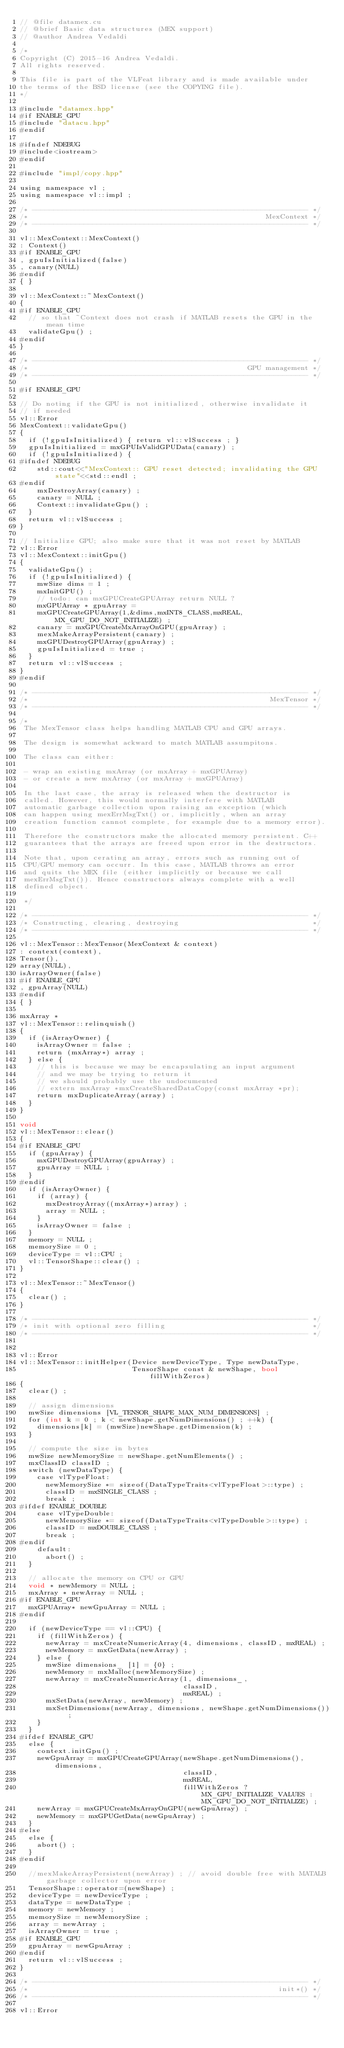<code> <loc_0><loc_0><loc_500><loc_500><_Cuda_>// @file datamex.cu
// @brief Basic data structures (MEX support)
// @author Andrea Vedaldi

/*
Copyright (C) 2015-16 Andrea Vedaldi.
All rights reserved.

This file is part of the VLFeat library and is made available under
the terms of the BSD license (see the COPYING file).
*/

#include "datamex.hpp"
#if ENABLE_GPU
#include "datacu.hpp"
#endif

#ifndef NDEBUG
#include<iostream>
#endif

#include "impl/copy.hpp"

using namespace vl ;
using namespace vl::impl ;

/* ---------------------------------------------------------------- */
/*                                                       MexContext */
/* ---------------------------------------------------------------- */

vl::MexContext::MexContext()
: Context()
#if ENABLE_GPU
, gpuIsInitialized(false)
, canary(NULL)
#endif
{ }

vl::MexContext::~MexContext()
{
#if ENABLE_GPU
  // so that ~Context does not crash if MATLAB resets the GPU in the mean time
  validateGpu() ;
#endif
}

/* ---------------------------------------------------------------- */
/*                                                   GPU management */
/* ---------------------------------------------------------------- */

#if ENABLE_GPU

// Do noting if the GPU is not initialized, otherwise invalidate it
// if needed
vl::Error
MexContext::validateGpu()
{
  if (!gpuIsInitialized) { return vl::vlSuccess ; }
  gpuIsInitialized = mxGPUIsValidGPUData(canary) ;
  if (!gpuIsInitialized) {
#ifndef NDEBUG
    std::cout<<"MexContext:: GPU reset detected; invalidating the GPU state"<<std::endl ;
#endif
    mxDestroyArray(canary) ;
    canary = NULL ;
    Context::invalidateGpu() ;
  }
  return vl::vlSuccess ;
}

// Initialize GPU; also make sure that it was not reset by MATLAB
vl::Error
vl::MexContext::initGpu()
{
  validateGpu() ;
  if (!gpuIsInitialized) {
    mwSize dims = 1 ;
    mxInitGPU() ;
    // todo: can mxGPUCreateGPUArray return NULL ?
    mxGPUArray * gpuArray =
    mxGPUCreateGPUArray(1,&dims,mxINT8_CLASS,mxREAL,MX_GPU_DO_NOT_INITIALIZE) ;
    canary = mxGPUCreateMxArrayOnGPU(gpuArray) ;
    mexMakeArrayPersistent(canary) ;
    mxGPUDestroyGPUArray(gpuArray) ;
    gpuIsInitialized = true ;
  }
  return vl::vlSuccess ;
}
#endif

/* ---------------------------------------------------------------- */
/*                                                        MexTensor */
/* ---------------------------------------------------------------- */

/*
 The MexTensor class helps handling MATLAB CPU and GPU arrays.

 The design is somewhat ackward to match MATLAB assumpitons.

 The class can either:

 - wrap an existing mxArray (or mxArray + mxGPUArray)
 - or create a new mxArray (or mxArray + mxGPUArray)

 In the last case, the array is released when the destructor is
 called. However, this would normally interfere with MATLAB
 automatic garbage collection upon raising an exception (which
 can happen using mexErrMsgTxt() or, implicitly, when an array
 creation function cannot complete, for example due to a memory error).

 Therefore the constructors make the allocated memory persistent. C++
 guarantees that the arrays are freeed upon error in the destructors.

 Note that, upon cerating an array, errors such as running out of
 CPU/GPU memory can occurr. In this case, MATLAB throws an error
 and quits the MEX file (either implicitly or because we call
 mexErrMsgTxt()). Hence constructors always complete with a well
 defined object.

 */

/* ---------------------------------------------------------------- */
/* Constructing, clearing, destroying                               */
/* ---------------------------------------------------------------- */

vl::MexTensor::MexTensor(MexContext & context)
: context(context),
Tensor(),
array(NULL),
isArrayOwner(false)
#if ENABLE_GPU
, gpuArray(NULL)
#endif
{ }

mxArray *
vl::MexTensor::relinquish()
{
  if (isArrayOwner) {
    isArrayOwner = false ;
    return (mxArray*) array ;
  } else {
    // this is because we may be encapsulating an input argument
    // and we may be trying to return it
    // we should probably use the undocumented
    // extern mxArray *mxCreateSharedDataCopy(const mxArray *pr);
    return mxDuplicateArray(array) ;
  }
}

void
vl::MexTensor::clear()
{
#if ENABLE_GPU
  if (gpuArray) {
    mxGPUDestroyGPUArray(gpuArray) ;
    gpuArray = NULL ;
  }
#endif
  if (isArrayOwner) {
    if (array) {
      mxDestroyArray((mxArray*)array) ;
      array = NULL ;
    }
    isArrayOwner = false ;
  }
  memory = NULL ;
  memorySize = 0 ;
  deviceType = vl::CPU ;
  vl::TensorShape::clear() ;
}

vl::MexTensor::~MexTensor()
{
  clear() ;
}

/* ---------------------------------------------------------------- */
/* init with optional zero filling                                  */
/* ---------------------------------------------------------------- */


vl::Error
vl::MexTensor::initHelper(Device newDeviceType, Type newDataType,
                          TensorShape const & newShape, bool fillWithZeros)
{
  clear() ;

  // assign dimensions
  mwSize dimensions [VL_TENSOR_SHAPE_MAX_NUM_DIMENSIONS] ;
  for (int k = 0 ; k < newShape.getNumDimensions() ; ++k) {
    dimensions[k] = (mwSize)newShape.getDimension(k) ;
  }

  // compute the size in bytes
  mwSize newMemorySize = newShape.getNumElements() ;
  mxClassID classID ;
  switch (newDataType) {
    case vlTypeFloat:
      newMemorySize *= sizeof(DataTypeTraits<vlTypeFloat>::type) ;
      classID = mxSINGLE_CLASS ;
      break ;
#ifdef ENABLE_DOUBLE
    case vlTypeDouble:
      newMemorySize *= sizeof(DataTypeTraits<vlTypeDouble>::type) ;
      classID = mxDOUBLE_CLASS ;
      break ;
#endif
    default:
      abort() ;
  }

  // allocate the memory on CPU or GPU
  void * newMemory = NULL ;
  mxArray * newArray = NULL ;
#if ENABLE_GPU
  mxGPUArray* newGpuArray = NULL ;
#endif

  if (newDeviceType == vl::CPU) {
    if (fillWithZeros) {
      newArray = mxCreateNumericArray(4, dimensions, classID, mxREAL) ;
      newMemory = mxGetData(newArray) ;
    } else {
      mwSize dimensions_ [1] = {0} ;
      newMemory = mxMalloc(newMemorySize) ;
      newArray = mxCreateNumericArray(1, dimensions_,
                                      classID,
                                      mxREAL) ;
      mxSetData(newArray, newMemory) ;
      mxSetDimensions(newArray, dimensions, newShape.getNumDimensions()) ;
    }
  }
#ifdef ENABLE_GPU
  else {
    context.initGpu() ;
    newGpuArray = mxGPUCreateGPUArray(newShape.getNumDimensions(), dimensions,
                                      classID,
                                      mxREAL,
                                      fillWithZeros ? MX_GPU_INITIALIZE_VALUES : MX_GPU_DO_NOT_INITIALIZE) ;
    newArray = mxGPUCreateMxArrayOnGPU(newGpuArray) ;
    newMemory = mxGPUGetData(newGpuArray) ;
  }
#else
  else {
    abort() ;
  }
#endif

  //mexMakeArrayPersistent(newArray) ; // avoid double free with MATALB garbage collector upon error
  TensorShape::operator=(newShape) ;
  deviceType = newDeviceType ;
  dataType = newDataType ;
  memory = newMemory ;
  memorySize = newMemorySize ;
  array = newArray ;
  isArrayOwner = true ;
#if ENABLE_GPU
  gpuArray = newGpuArray ;
#endif
  return vl::vlSuccess ;
}

/* ---------------------------------------------------------------- */
/*                                                          init*() */
/* ---------------------------------------------------------------- */

vl::Error</code> 